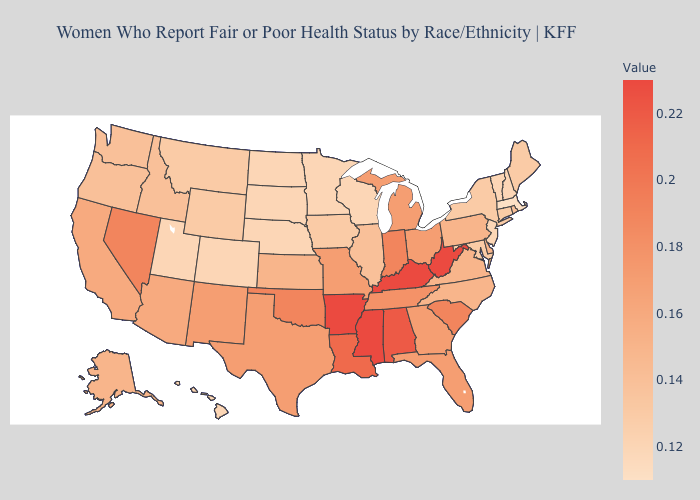Which states have the lowest value in the USA?
Quick response, please. Massachusetts. Which states have the highest value in the USA?
Be succinct. Arkansas, Kentucky, Mississippi, West Virginia. Does Wisconsin have the lowest value in the MidWest?
Keep it brief. Yes. Does Massachusetts have the lowest value in the USA?
Be succinct. Yes. Which states have the lowest value in the Northeast?
Answer briefly. Massachusetts. 